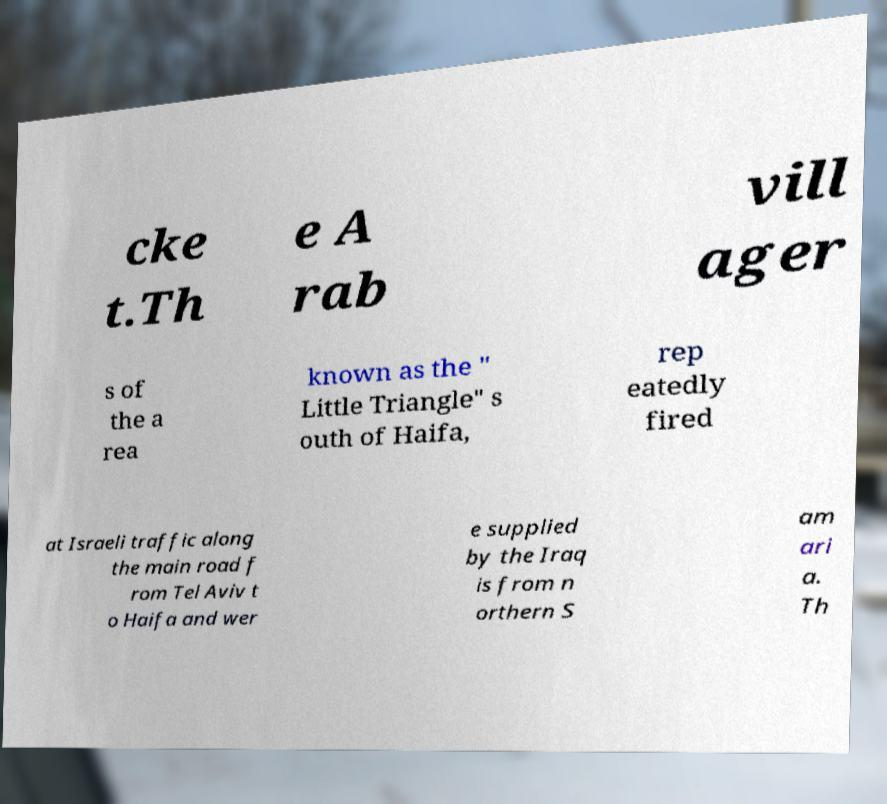What messages or text are displayed in this image? I need them in a readable, typed format. cke t.Th e A rab vill ager s of the a rea known as the " Little Triangle" s outh of Haifa, rep eatedly fired at Israeli traffic along the main road f rom Tel Aviv t o Haifa and wer e supplied by the Iraq is from n orthern S am ari a. Th 